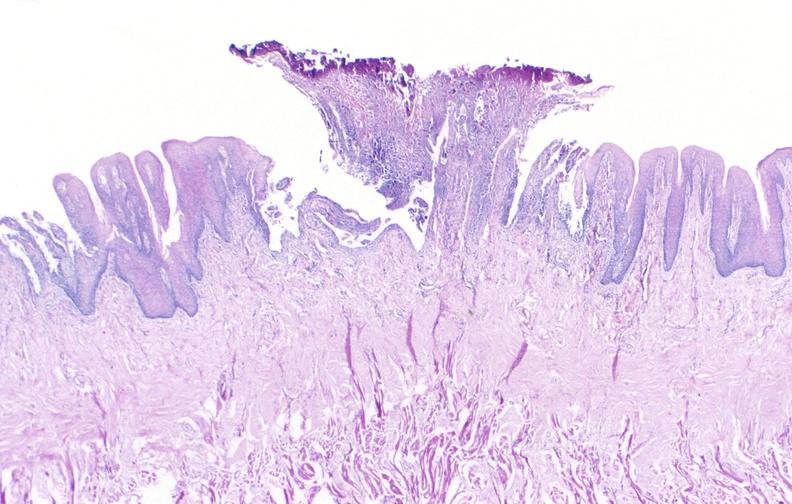what is present?
Answer the question using a single word or phrase. Gastrointestinal 